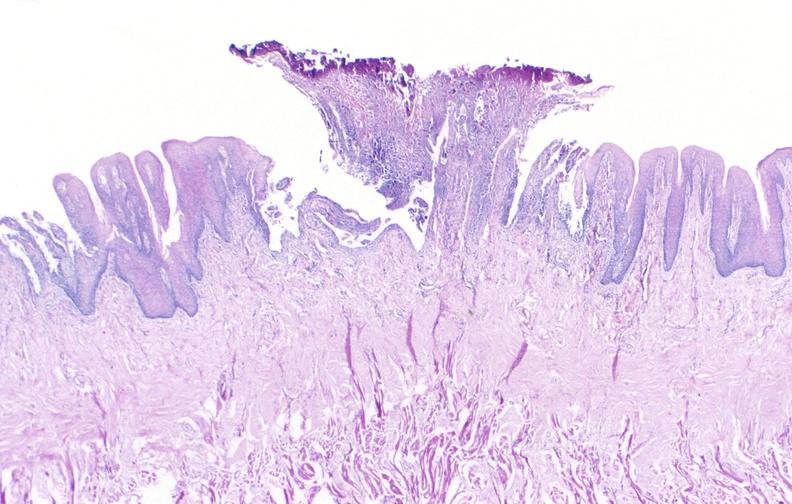what is present?
Answer the question using a single word or phrase. Gastrointestinal 